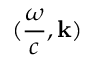<formula> <loc_0><loc_0><loc_500><loc_500>( { \frac { \omega } { c } } , k )</formula> 